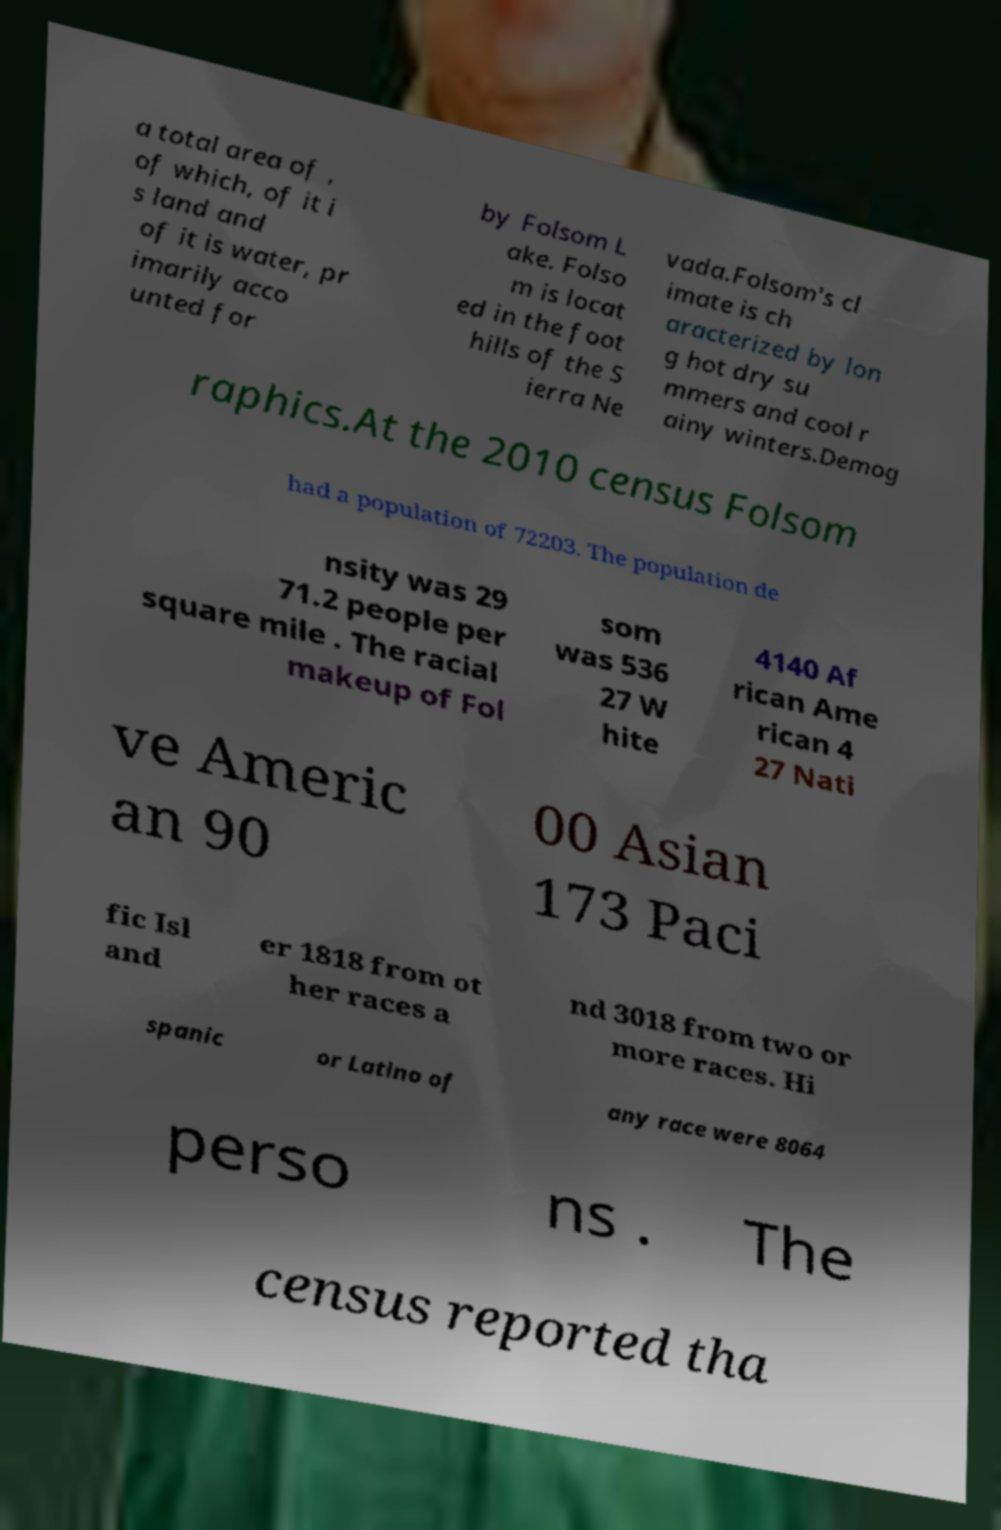Please read and relay the text visible in this image. What does it say? a total area of , of which, of it i s land and of it is water, pr imarily acco unted for by Folsom L ake. Folso m is locat ed in the foot hills of the S ierra Ne vada.Folsom's cl imate is ch aracterized by lon g hot dry su mmers and cool r ainy winters.Demog raphics.At the 2010 census Folsom had a population of 72203. The population de nsity was 29 71.2 people per square mile . The racial makeup of Fol som was 536 27 W hite 4140 Af rican Ame rican 4 27 Nati ve Americ an 90 00 Asian 173 Paci fic Isl and er 1818 from ot her races a nd 3018 from two or more races. Hi spanic or Latino of any race were 8064 perso ns . The census reported tha 